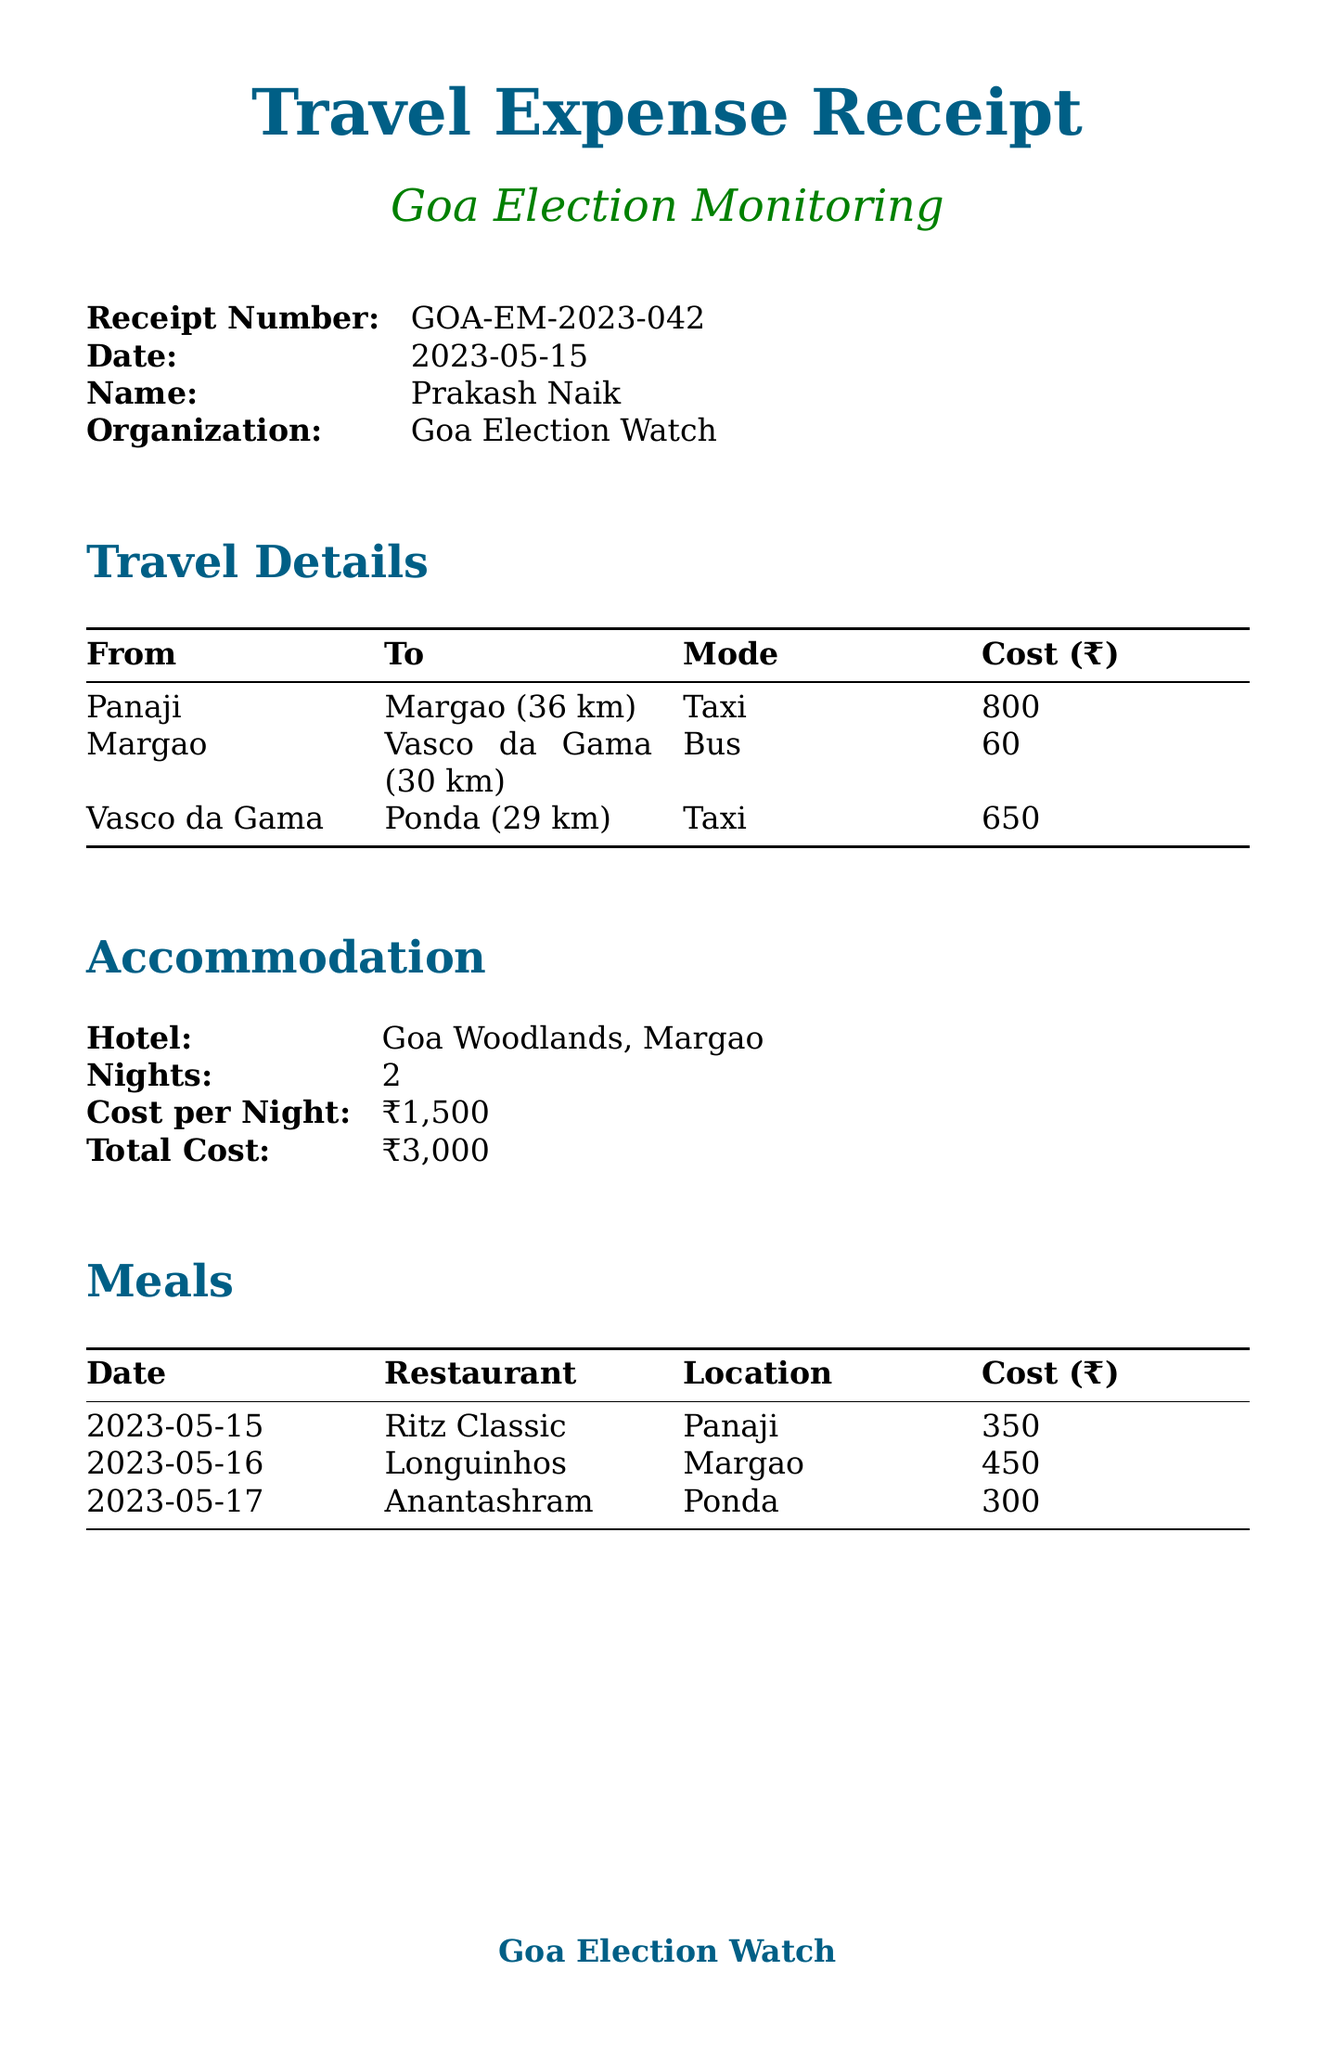What is the receipt number? The receipt number is listed at the top of the document as a unique identifier for the expense report.
Answer: GOA-EM-2023-042 Who is the person associated with this expense report? The name of the individual responsible for the expenses is clearly mentioned in the document.
Answer: Prakash Naik How many nights was accommodation booked for? The number of nights stayed at the hotel is specified under the accommodation section.
Answer: 2 What was the total cost for transportation? The total cost for transportation can be calculated from the individual travel expenses listed in the document.
Answer: 1510 What is the purpose of the travel? The purpose of the travel is explicitly stated at the end of the document.
Answer: Monitor pre-election preparations and voter awareness campaigns How many meals are listed in the document? By counting the meal entries provided in the meals section, we can determine the quantity of meals.
Answer: 3 Who approved the expenses? The document includes a section that names the person responsible for approving the expenses.
Answer: Sanjay Dessai, Treasurer, Goa Election Watch What is the total expense amount reported? The total expenses are clearly indicated in the summary towards the end of the document.
Answer: 6304 